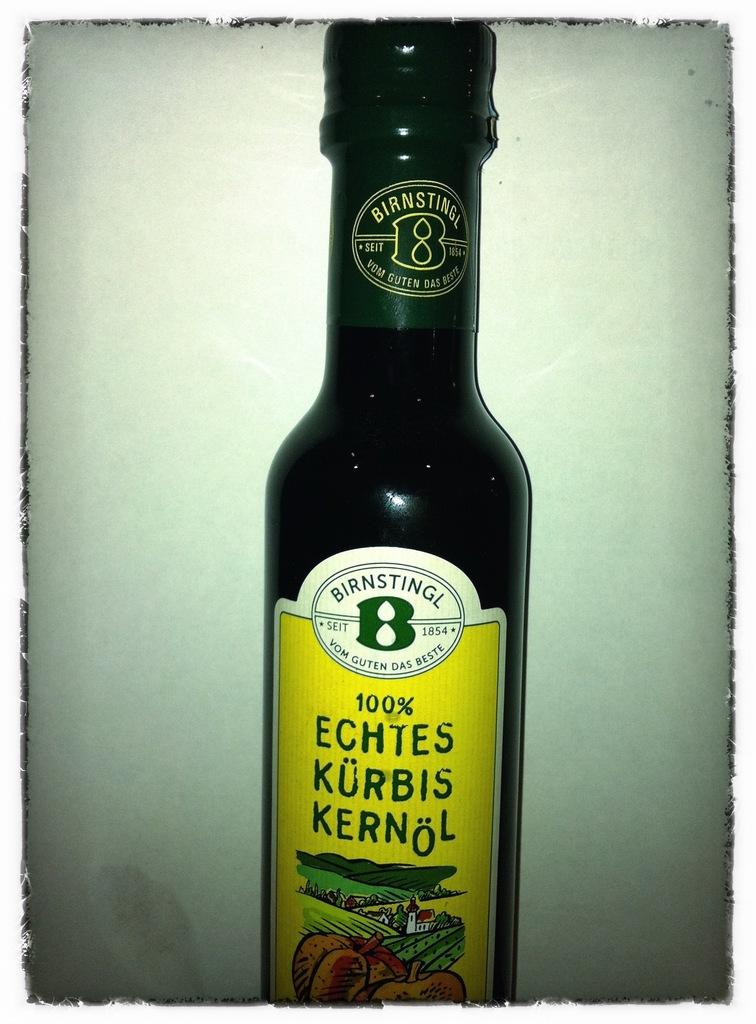<image>
Relay a brief, clear account of the picture shown. A bottle which has the word Birnstingl in capital letters on the label. 